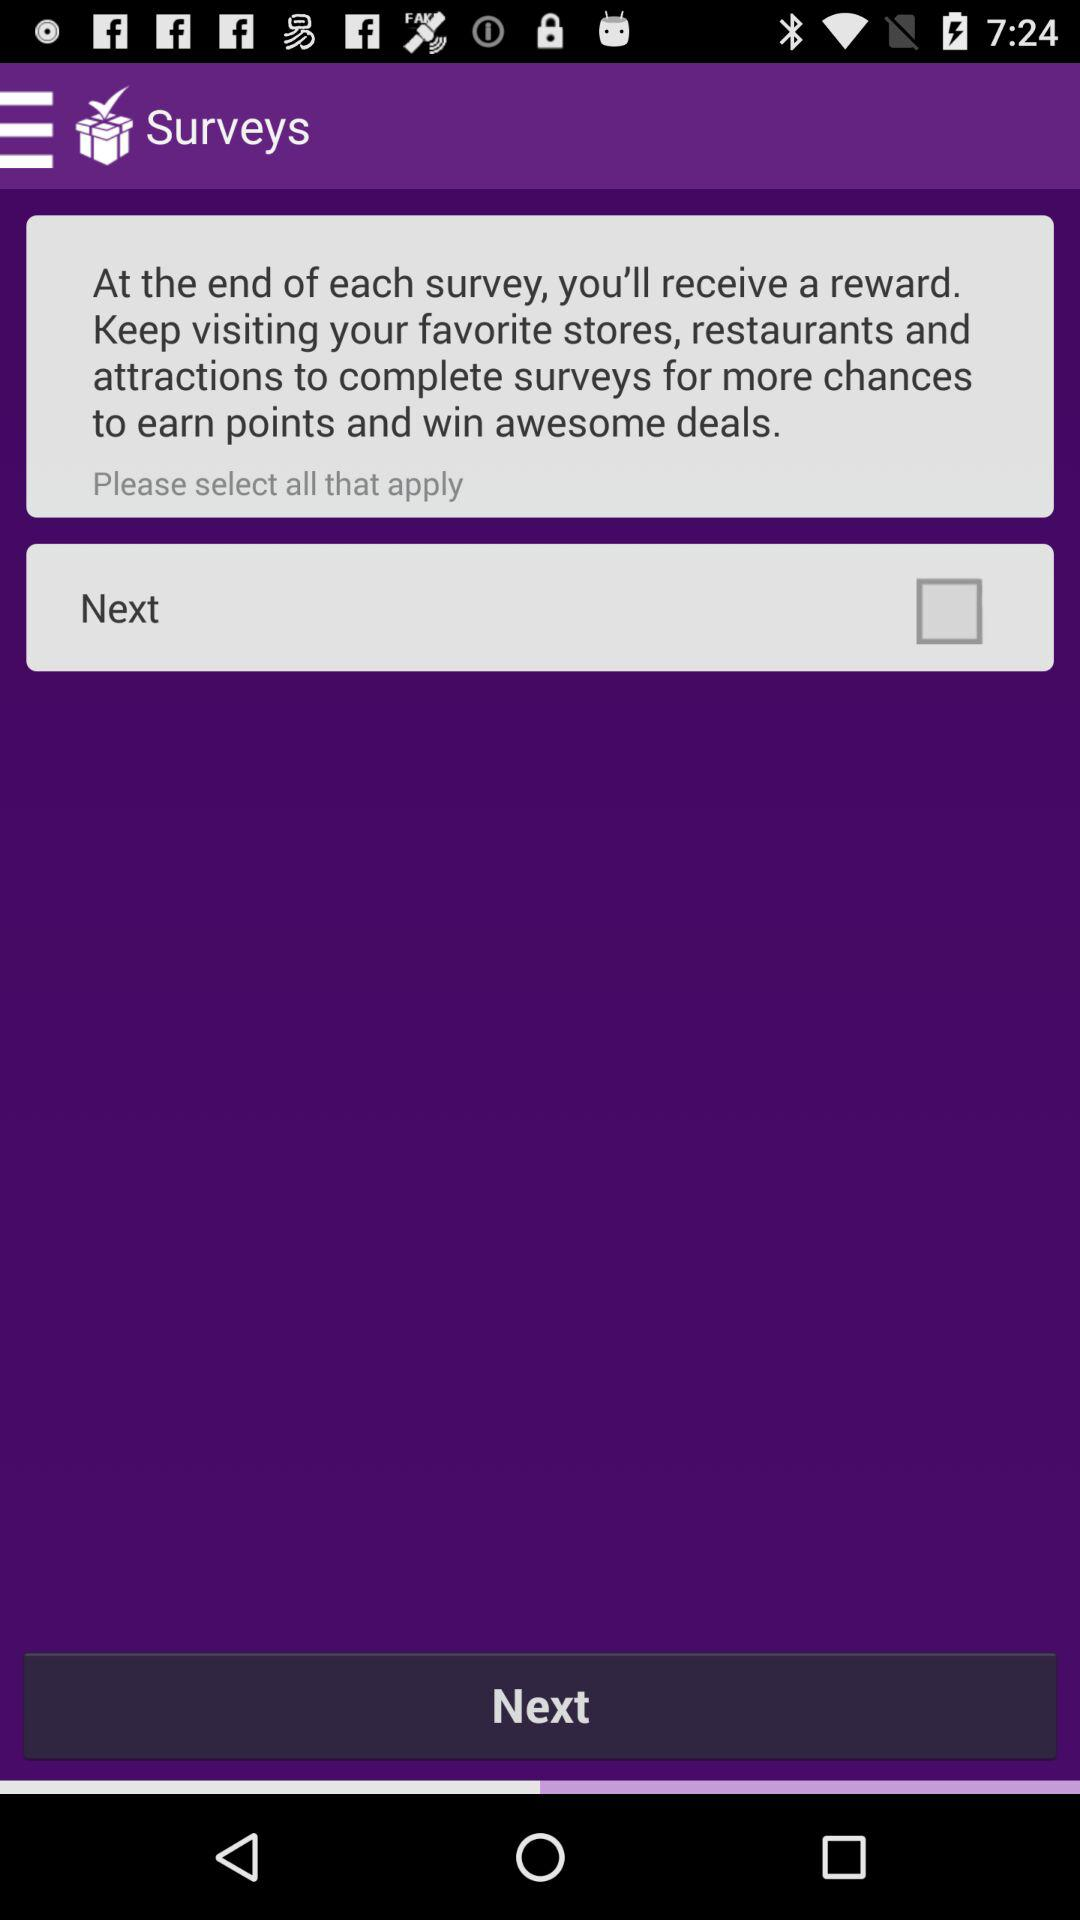What is the user's name?
When the provided information is insufficient, respond with <no answer>. <no answer> 